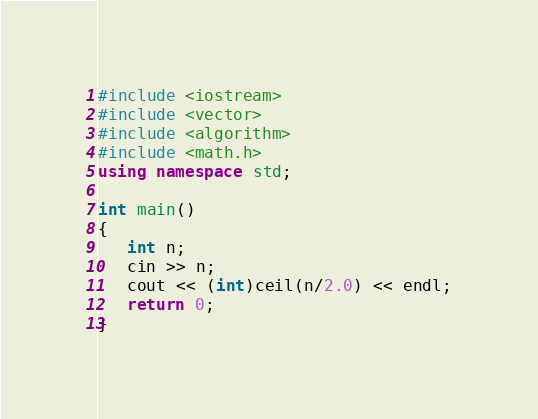<code> <loc_0><loc_0><loc_500><loc_500><_C++_>#include <iostream>
#include <vector>
#include <algorithm>
#include <math.h>
using namespace std;

int main()
{
   int n;
   cin >> n;
   cout << (int)ceil(n/2.0) << endl;
   return 0;
}</code> 